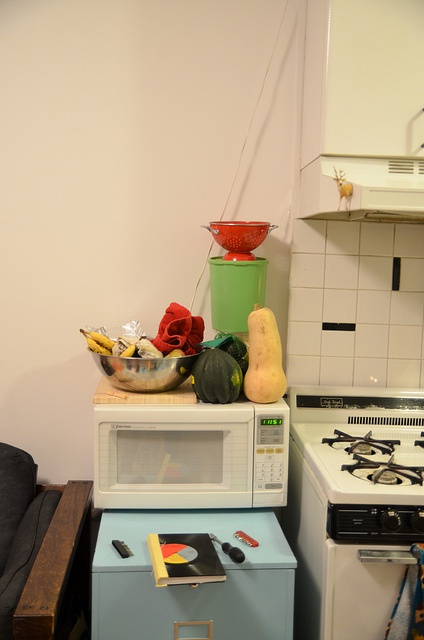Describe the objects in this image and their specific colors. I can see oven in tan and black tones, microwave in tan tones, couch in tan, black, maroon, and gray tones, book in tan, black, khaki, and darkgray tones, and bowl in tan, gray, black, and brown tones in this image. 